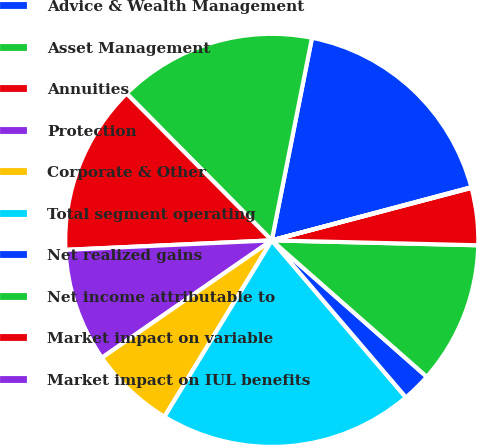Convert chart. <chart><loc_0><loc_0><loc_500><loc_500><pie_chart><fcel>Advice & Wealth Management<fcel>Asset Management<fcel>Annuities<fcel>Protection<fcel>Corporate & Other<fcel>Total segment operating<fcel>Net realized gains<fcel>Net income attributable to<fcel>Market impact on variable<fcel>Market impact on IUL benefits<nl><fcel>17.74%<fcel>15.53%<fcel>13.32%<fcel>8.89%<fcel>6.68%<fcel>19.95%<fcel>2.26%<fcel>11.11%<fcel>4.47%<fcel>0.05%<nl></chart> 